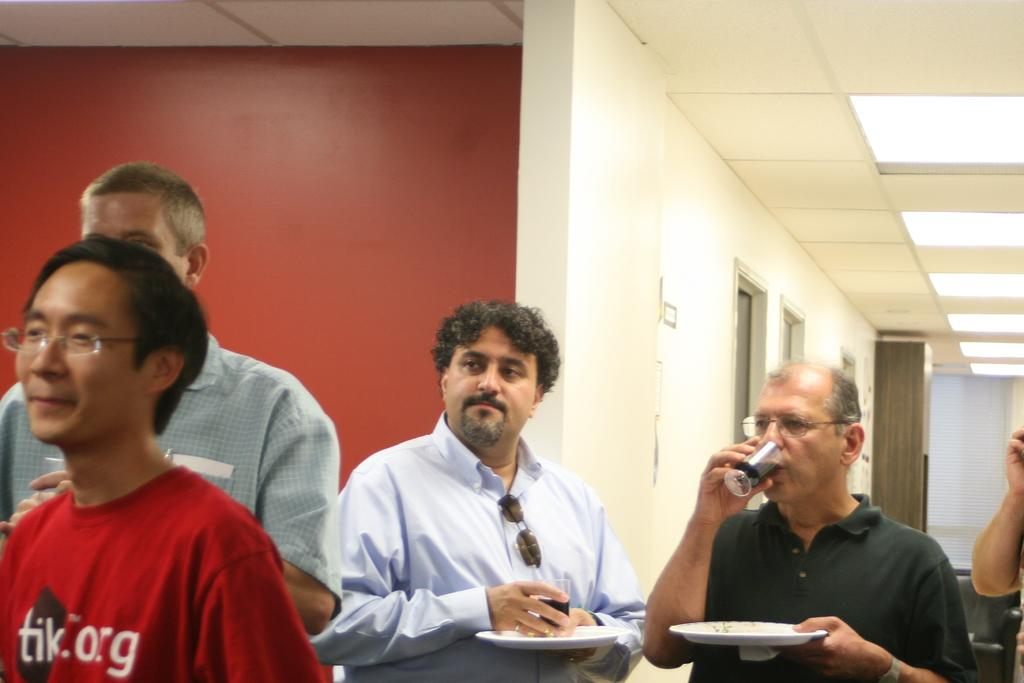How many persons are in the image? There are persons in the image, but the exact number is not specified. What are some of the persons doing in the image? Some of the persons are holding objects in the image. What type of structure can be seen in the image? There is a wall visible in the image, and there are doors and a roof visible as well. What type of illumination is present in the image? There are lights in the image. Can you tell me how many grapes are being held by the persons in the image? There is no mention of grapes in the image, so it is not possible to determine how many grapes are being held. Are there any slaves depicted in the image? The term "slave" is not mentioned in the image, and there is no indication of any such depiction. 